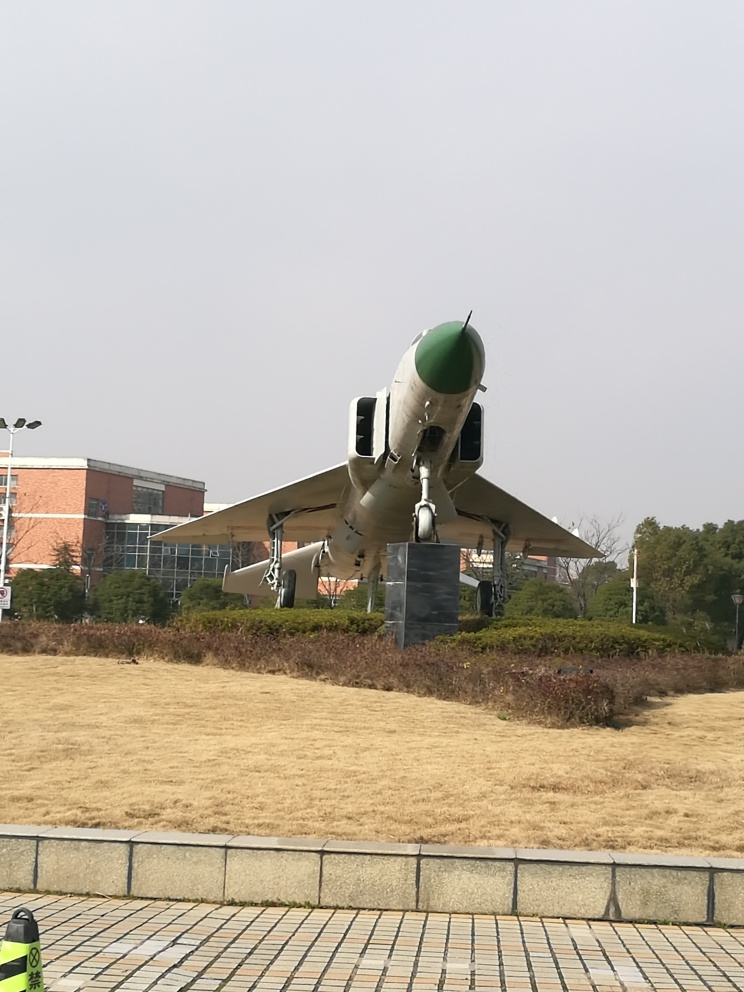What do you imagine the history of this jet might be? Given its displayed state on a pedestal, it's possible that this jet has a storied past. It may have been involved in significant military campaigns or aerial feats, and could have served one or several nations throughout its operational life. Retiring a jet to a display such as this usually implies that it played a notable role, and now serves as a static exhibit, perhaps as a way to educate the public about its historical importance and the technological developments it embodies. 